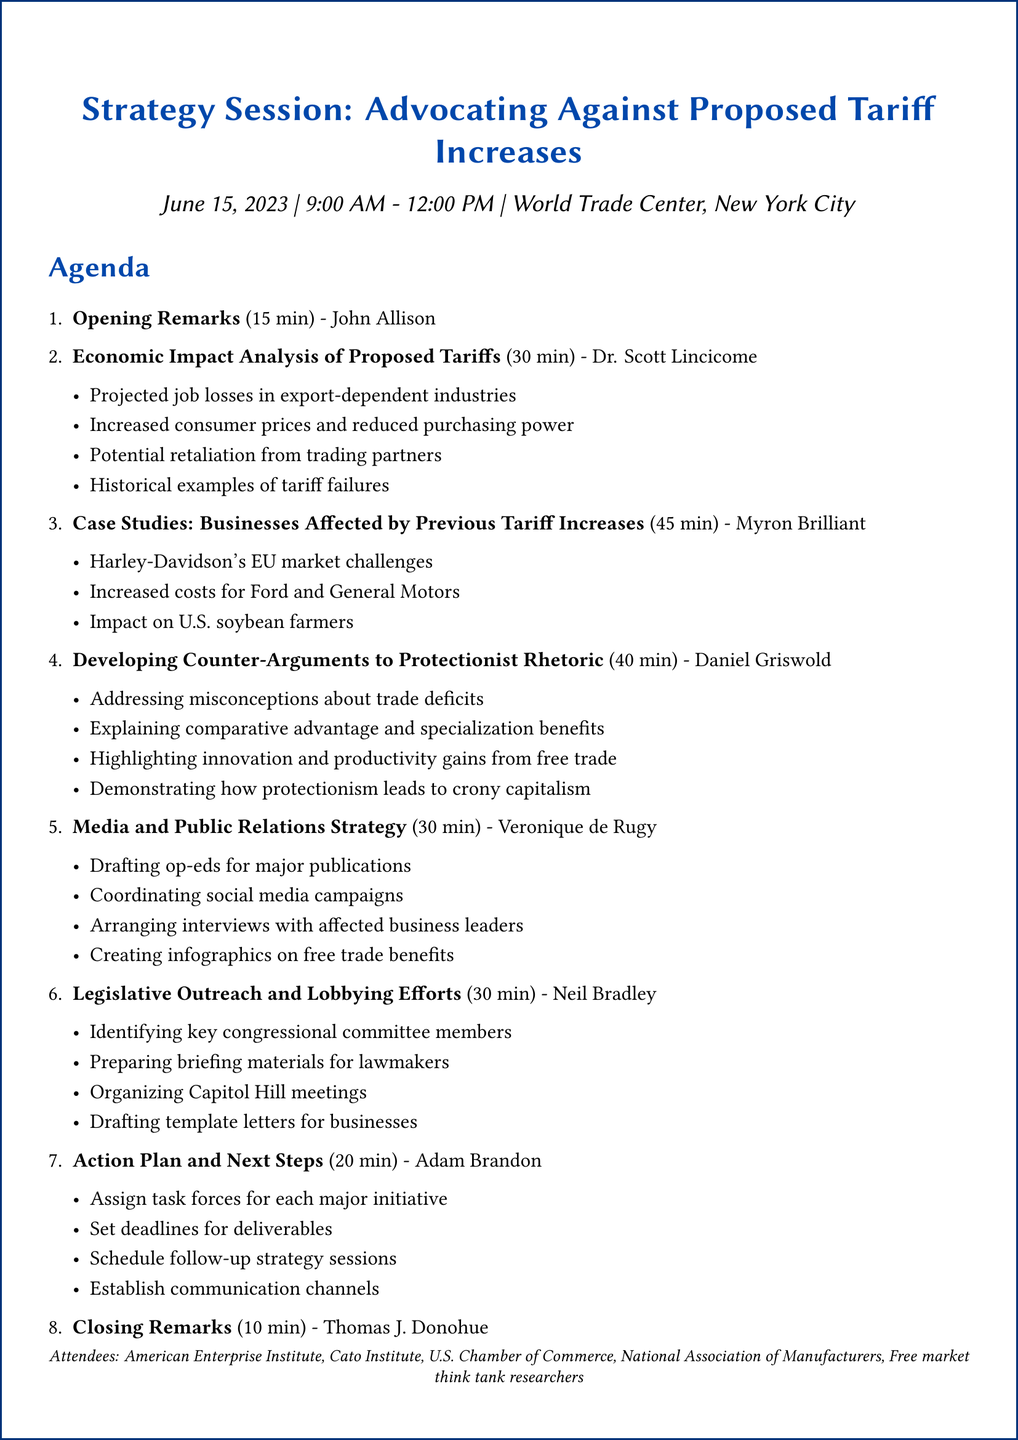what is the title of the meeting? The title of the meeting is specified in the document as "Strategy Session: Advocating Against Proposed Tariff Increases".
Answer: Strategy Session: Advocating Against Proposed Tariff Increases who is the facilitator for the session on developing counter-arguments? The facilitator for this session is mentioned in the agenda, providing a clear identification of the role.
Answer: Daniel Griswold how long is the session on economic impact analysis scheduled for? The duration of the session on economic impact analysis is listed in the agenda, indicating the time allocated.
Answer: 30 minutes which organization is represented by Myron Brilliant at the meeting? The document specifies that Myron Brilliant is an Executive Vice President representing the U.S. Chamber of Commerce.
Answer: U.S. Chamber of Commerce what are the focus areas for the legislative outreach session? The focus areas are detailed in the agenda, covering specific aspects to be discussed during that session.
Answer: Identifying key congressional committee members to target, Preparing briefing materials for lawmakers, Organizing Capitol Hill meetings with affected industry representatives, Drafting template letters for businesses to send to their representatives what time does the meeting start? The starting time of the meeting is clearly noted in the document, indicating when the proceedings will begin.
Answer: 9:00 AM who will deliver the closing remarks? The document specifies the individual responsible for delivering the closing remarks, providing clarity on the agenda structure.
Answer: Thomas J. Donohue what is one of the action items in the media and public relations strategy? The agenda includes specific action items for the media strategy, highlighting tasks to be accomplished.
Answer: Drafting op-eds for major publications how many attendees are listed in the document? The document provides an overview of the organizations present at the meeting, indicating the diversity of the attendees.
Answer: Five organizations 